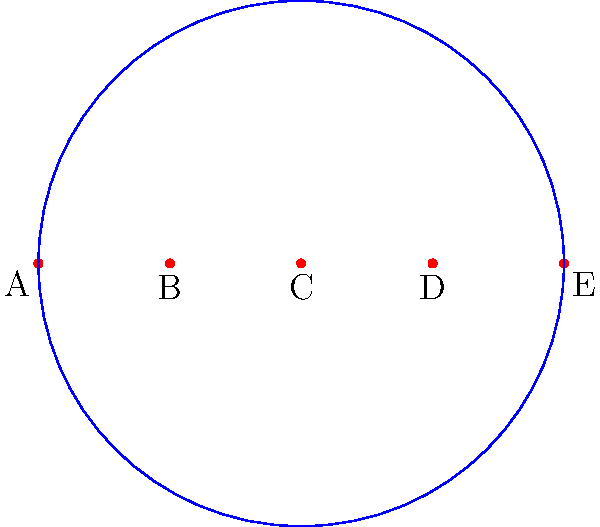In a corps de ballet formation, five dancers (A, B, C, D, and E) are positioned in a straight line. The choreography involves rotations and reflections around the central dancer C. If a 72° clockwise rotation followed by a reflection across the line is applied, what is the resulting permutation of the dancers in cycle notation? Let's approach this step-by-step:

1) First, let's consider the 72° clockwise rotation:
   - A moves to E's position
   - B moves to D's position
   - C stays in place (center of rotation)
   - D moves to A's position
   - E moves to B's position
   This gives us the permutation (AEDBA)

2) Now, we apply a reflection across the line:
   - A and E swap positions
   - B and D swap positions
   - C stays in place

3) Combining these operations:
   - A (which was at E's position) moves to A's position
   - E (which was at B's position) moves to E's position
   - D (which was at A's position) moves to B's position
   - B (which was at D's position) moves to D's position
   - C stays in place

4) We can write this as cycle notation:
   (BD) represents B moving to D's position and D to B's
   (AE) represents A and E swapping positions
   C is a fixed point, so it's not included in any cycle

Therefore, the resulting permutation in cycle notation is (BD)(AE).
Answer: (BD)(AE) 